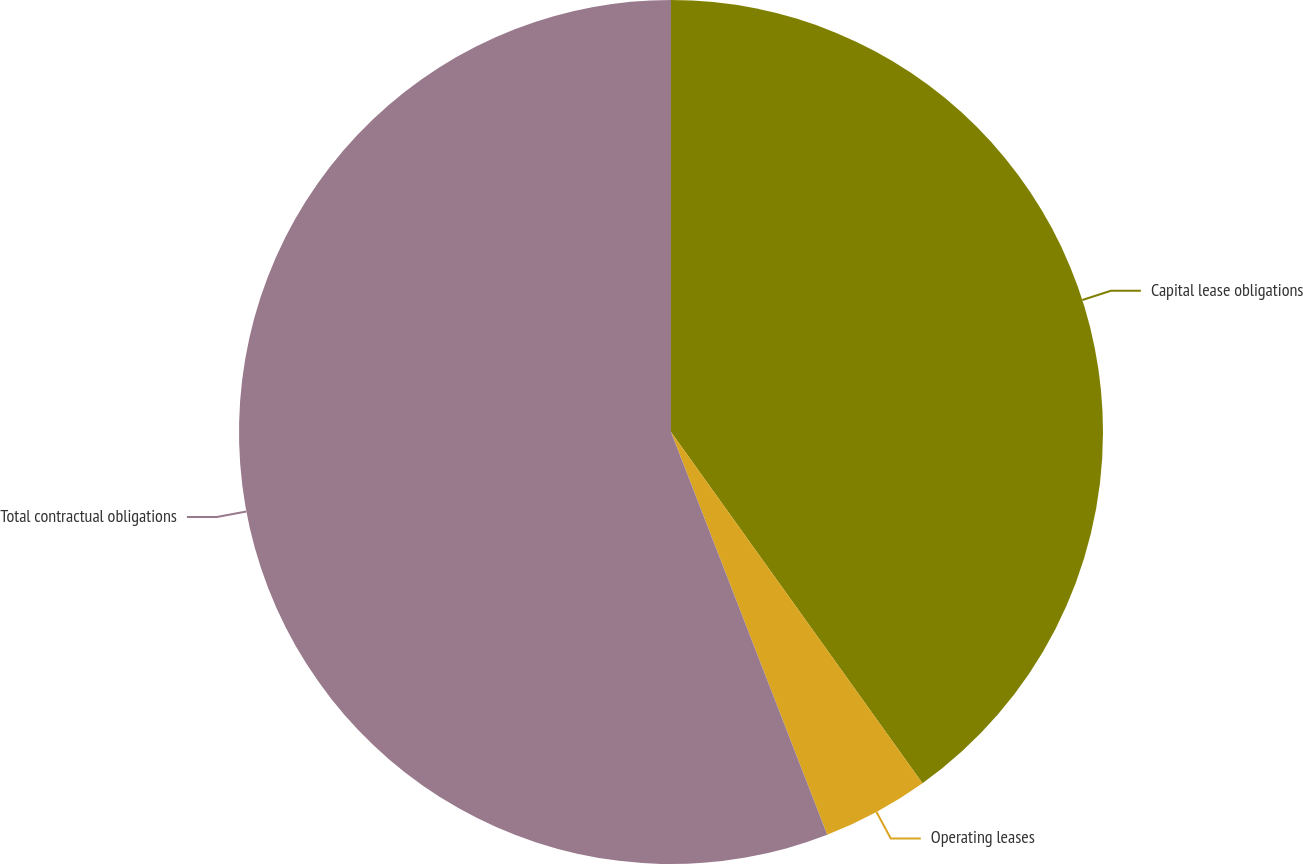<chart> <loc_0><loc_0><loc_500><loc_500><pie_chart><fcel>Capital lease obligations<fcel>Operating leases<fcel>Total contractual obligations<nl><fcel>40.11%<fcel>4.0%<fcel>55.89%<nl></chart> 